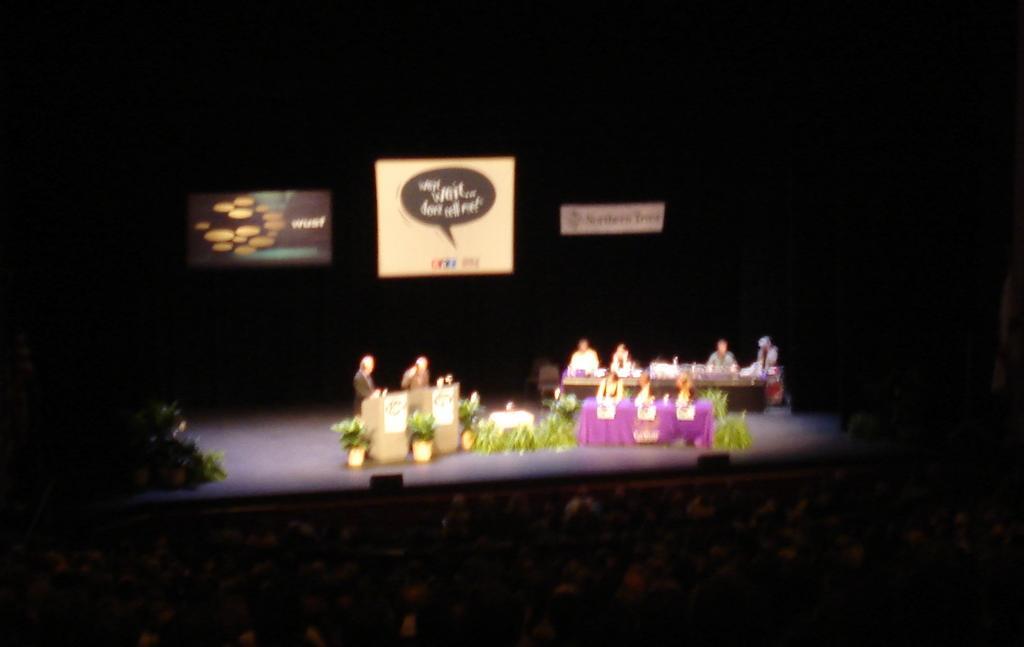Can you describe this image briefly? In this image there are group of people , stage , podiums, tables, plants, screen. 